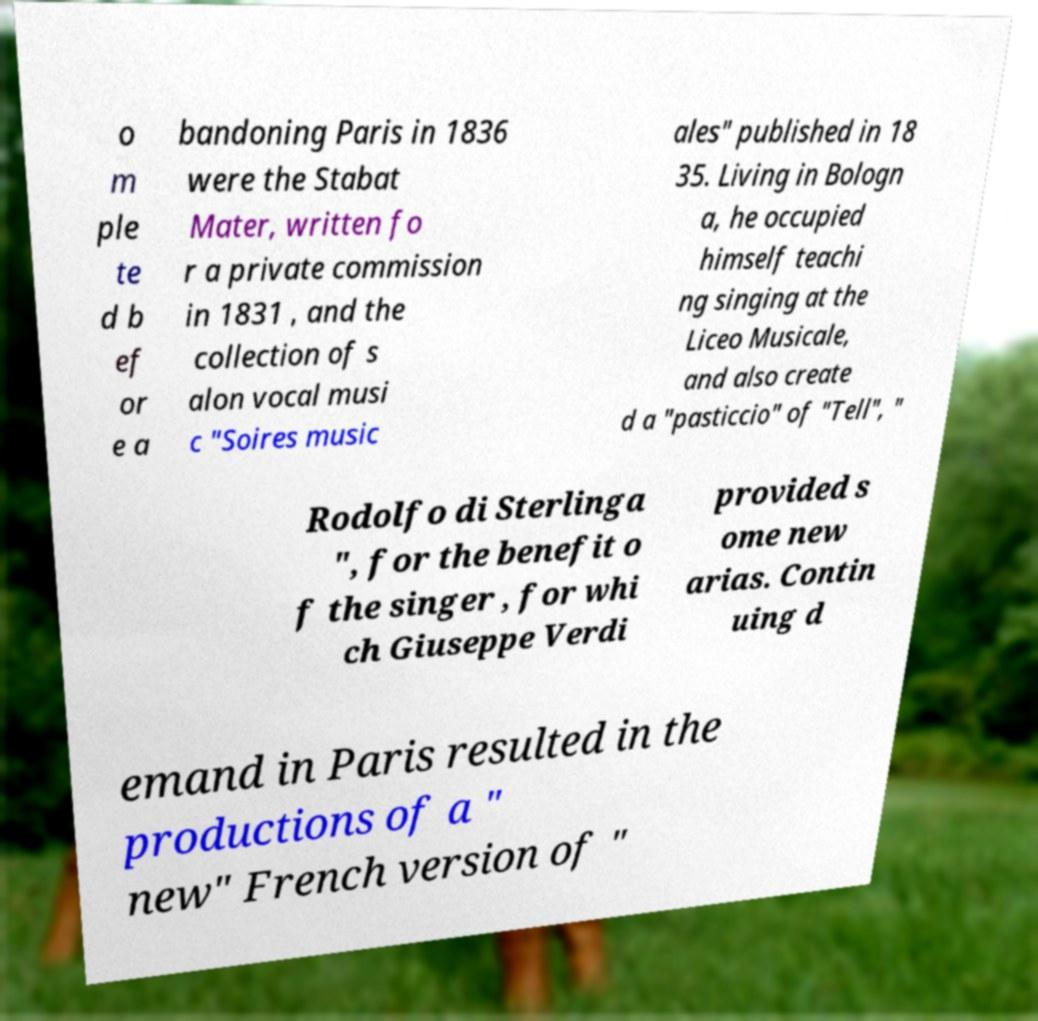Can you read and provide the text displayed in the image?This photo seems to have some interesting text. Can you extract and type it out for me? o m ple te d b ef or e a bandoning Paris in 1836 were the Stabat Mater, written fo r a private commission in 1831 , and the collection of s alon vocal musi c "Soires music ales" published in 18 35. Living in Bologn a, he occupied himself teachi ng singing at the Liceo Musicale, and also create d a "pasticcio" of "Tell", " Rodolfo di Sterlinga ", for the benefit o f the singer , for whi ch Giuseppe Verdi provided s ome new arias. Contin uing d emand in Paris resulted in the productions of a " new" French version of " 